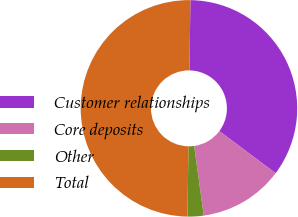<chart> <loc_0><loc_0><loc_500><loc_500><pie_chart><fcel>Customer relationships<fcel>Core deposits<fcel>Other<fcel>Total<nl><fcel>35.01%<fcel>12.59%<fcel>2.4%<fcel>50.0%<nl></chart> 